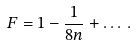<formula> <loc_0><loc_0><loc_500><loc_500>F = 1 - \frac { 1 } { 8 n } + \dots \, .</formula> 